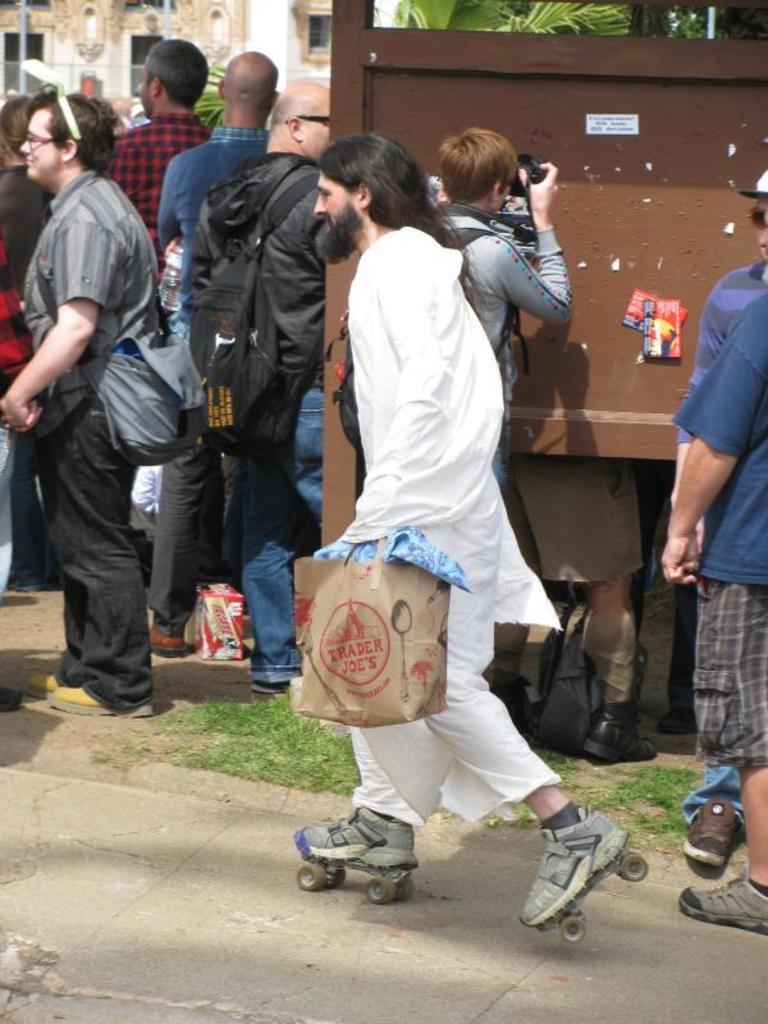Could you give a brief overview of what you see in this image? In this picture there is a person with white dress is skating and holding the bag and there is a person standing and holding the camera and there are group of people standing and there are papers on the board. At the back there is a building and there are trees and there is a pole. At the bottom there is a pavement and there is grass and box. 